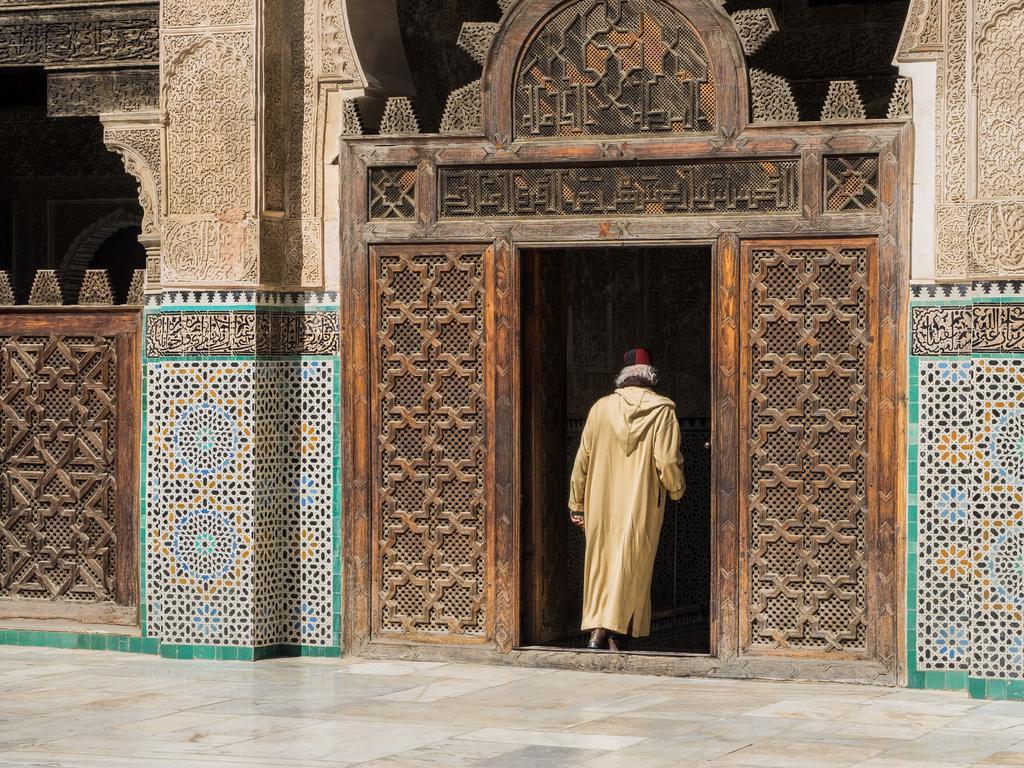How would you summarize this image in a sentence or two? In the image there is a building with walls, pillars, arches and doors. All those things are with designs. And also there is a man. At the bottom of the image there is a floor with tiles. 